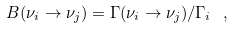Convert formula to latex. <formula><loc_0><loc_0><loc_500><loc_500>B ( \nu _ { i } \to \nu _ { j } ) = \Gamma ( \nu _ { i } \to \nu _ { j } ) / \Gamma _ { i } \ ,</formula> 